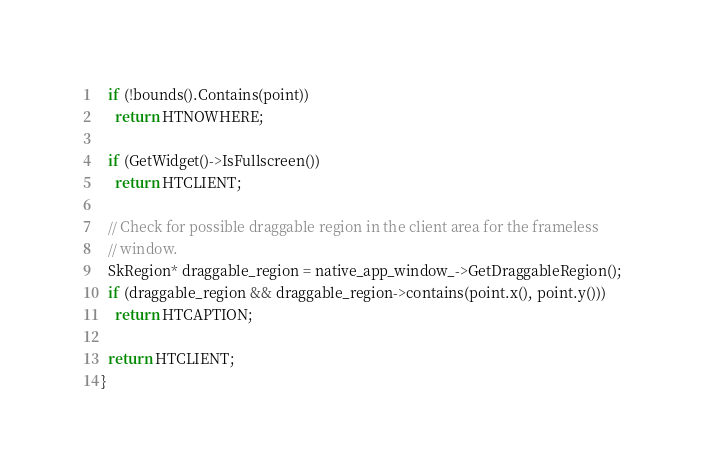<code> <loc_0><loc_0><loc_500><loc_500><_ObjectiveC_>  if (!bounds().Contains(point))
    return HTNOWHERE;

  if (GetWidget()->IsFullscreen())
    return HTCLIENT;

  // Check for possible draggable region in the client area for the frameless
  // window.
  SkRegion* draggable_region = native_app_window_->GetDraggableRegion();
  if (draggable_region && draggable_region->contains(point.x(), point.y()))
    return HTCAPTION;

  return HTCLIENT;
}
</code> 